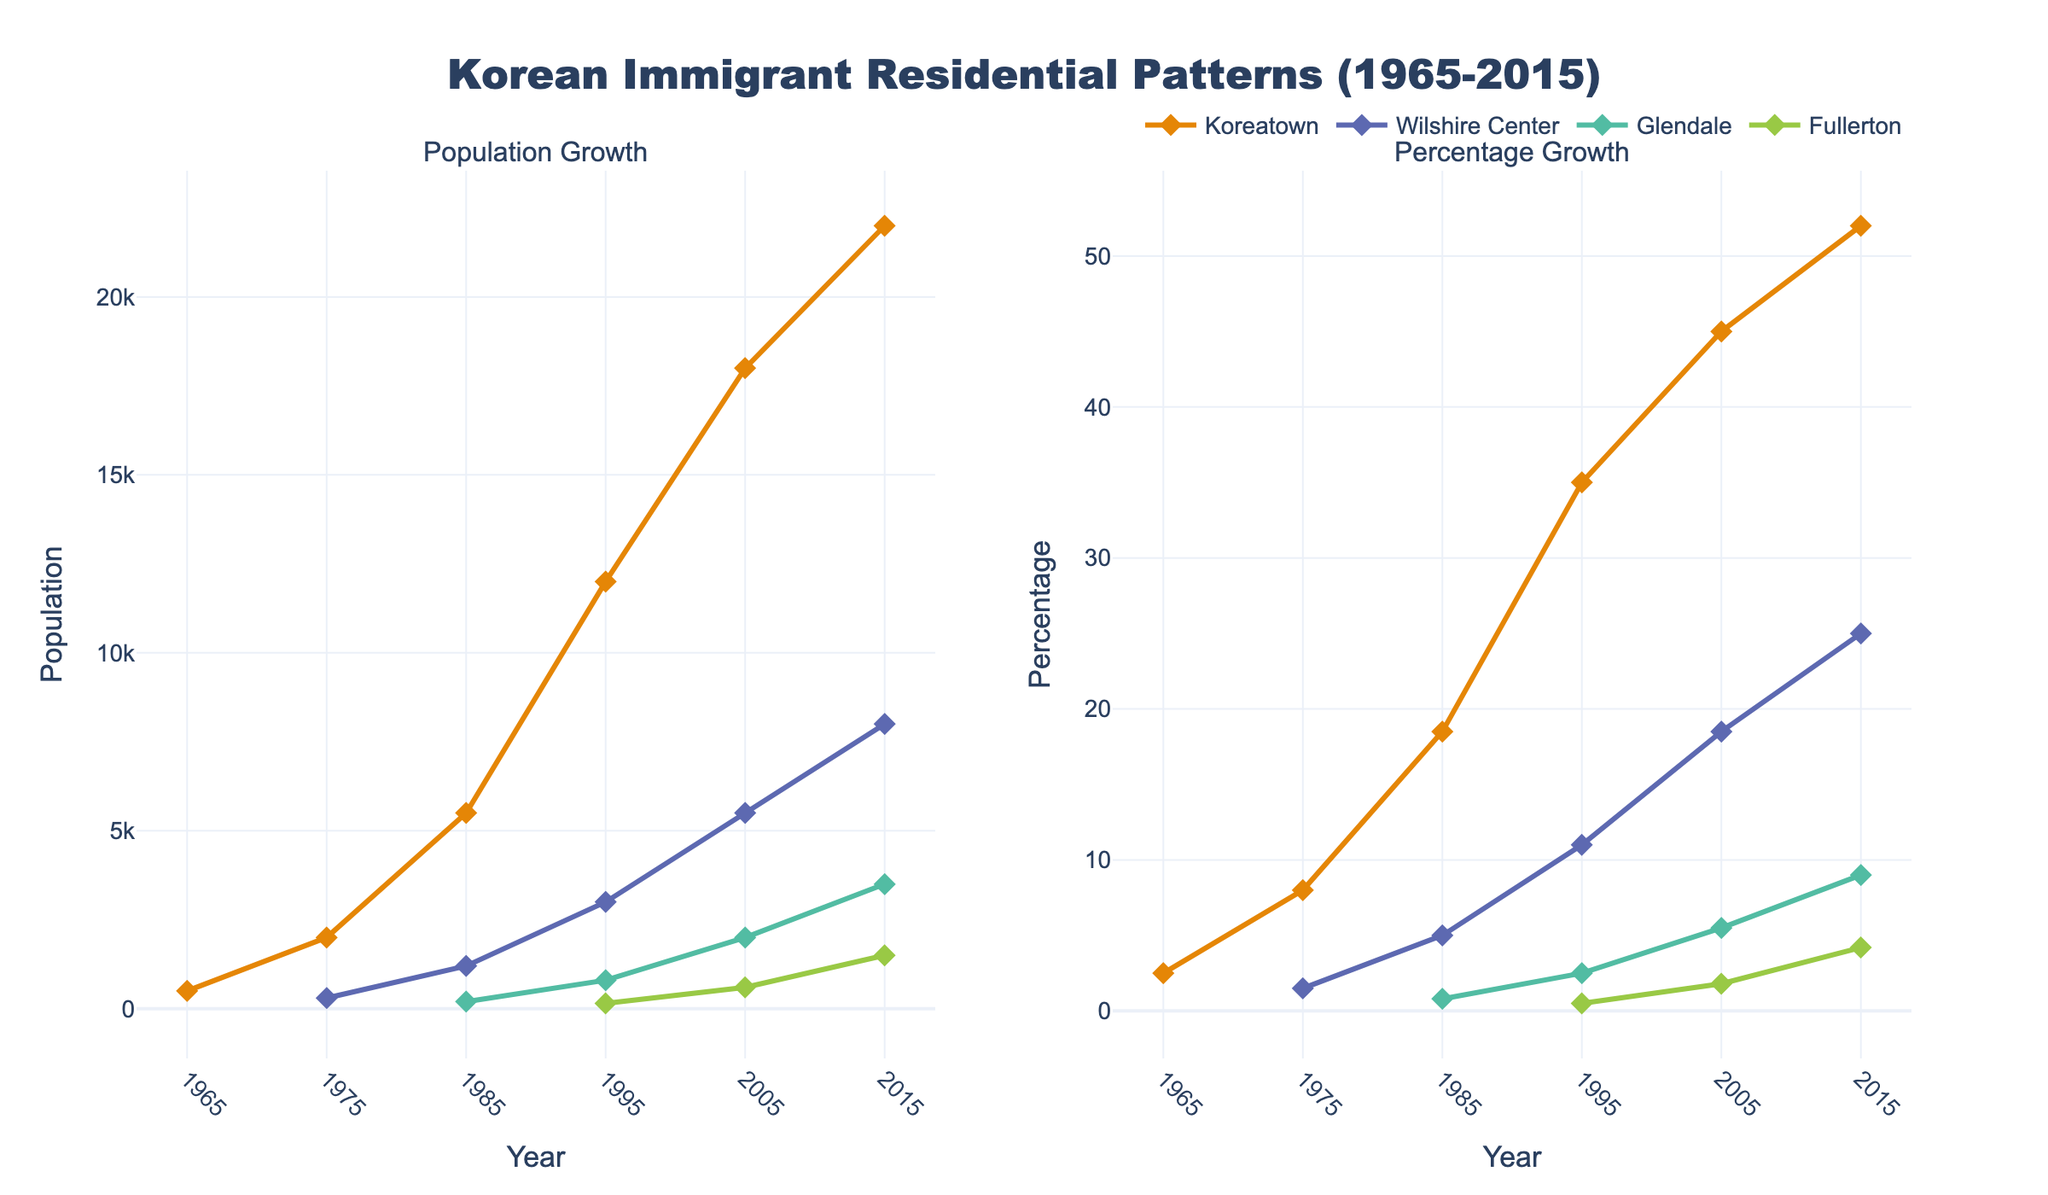What's the title of the figure? The title of the figure is displayed prominently at the top of the plot. It is written in large, bold text to provide a quick summary of the displayed data.
Answer: Korean Immigrant Residential Patterns (1965-2015) In which year did Koreatown see the highest population of Korean immigrants? By examining the 'Population Growth' plot, we can see the highest population value represented by the line and markers for Koreatown.
Answer: 2015 Which neighborhood had the highest percentage of Korean immigrants in 2005? We should look at the 'Percentage Growth' plot for the year 2005 and compare the percentage values for all neighborhoods.
Answer: Koreatown How many neighborhoods have data points in both subplots for the year 1995? By viewing both the 'Population Growth' and 'Percentage Growth' subplots and locating the year 1995, we can count the neighborhoods that have data points in both plots.
Answer: Three (Koreatown, Wilshire Center, Glendale) What is the difference in the percentage of Korean immigrants in Wilshire Center between 1985 and 2015? We need to find the percentage values for Wilshire Center in both years and subtract the 1985 value from the 2015 value. The percentages are found on the 'Percentage Growth' subplot.
Answer: 20.0 How did the population of Korean immigrants in Glendale change from 2005 to 2015? To determine this, we look at the 'Population Growth' plot and compare the population values for Glendale in 2005 and 2015.
Answer: Increase Which neighborhood experienced the most rapid growth in the percentage of Korean immigrants between 1995 and 2005? Beneath the 'Percentage Growth' subplot, we compare the percentage points for each neighborhood in 1995 and 2005. We calculate the difference for each and see which is the highest.
Answer: Koreatown What trend can be observed in the population of Korean immigrants in Fullerton from 1995 to 2015? By looking at the 'Population Growth' plot, we trace the data points for Fullerton and observe the direction of the trend line over these years.
Answer: Increasing Which two neighborhoods have intersecting population trends in any given year? To identify this, we should inspect the 'Population Growth' subplot to find any year where lines representing different neighborhoods cross each other.
Answer: Koreatown and Wilshire Center (2005) Is there any neighborhood where the percentage of Korean immigrants surpassed 50%? We examine the 'Percentage Growth' plot and check if any neighborhood's line crosses the 50% mark.
Answer: Yes (Koreatown in 2015) 